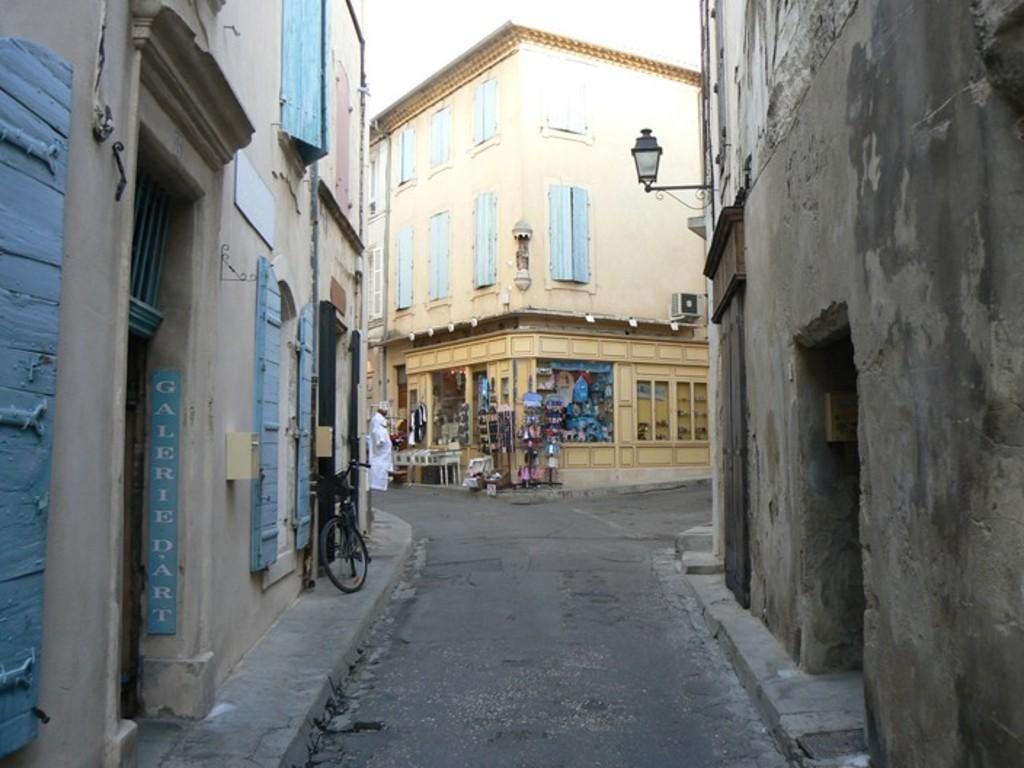How would you summarize this image in a sentence or two? In this picture I can see the buildings. On the left there is a bicycle which is parked near to the windows and doors. In the back there is a man is wearing white dress. He is standing in front of the shop. In the shop I can see the table, chairs and other objects. At the top I can see the sky. 